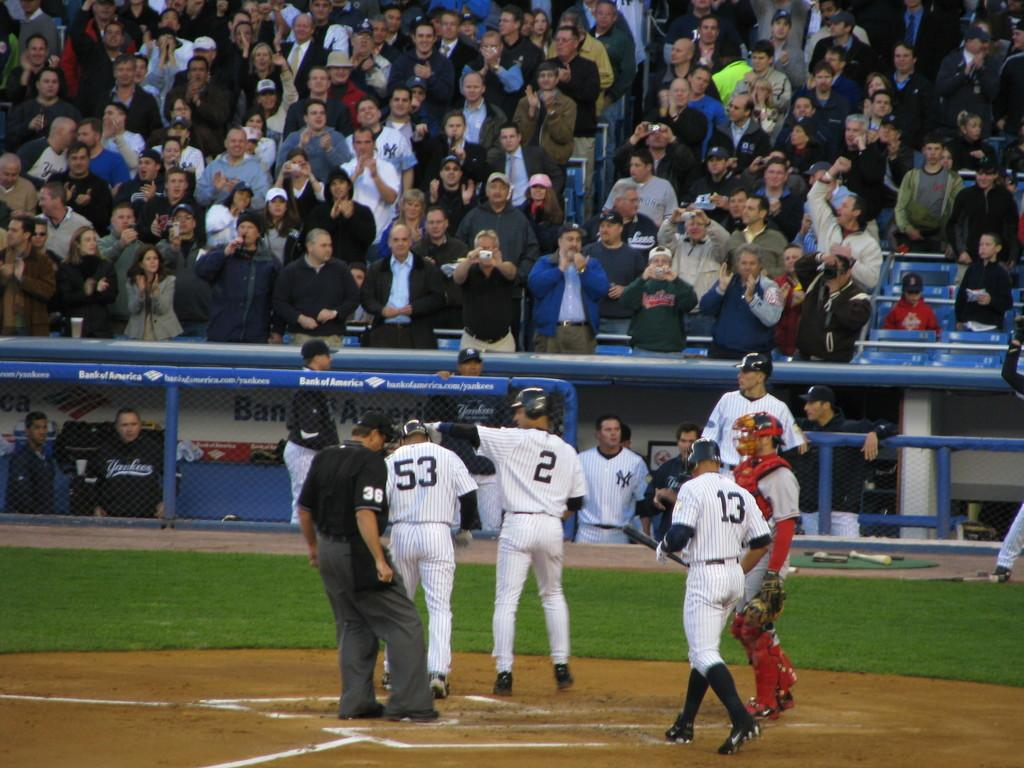<image>
Create a compact narrative representing the image presented. A bunch of baseball players and an umpire with the number 36 on his right arm. 